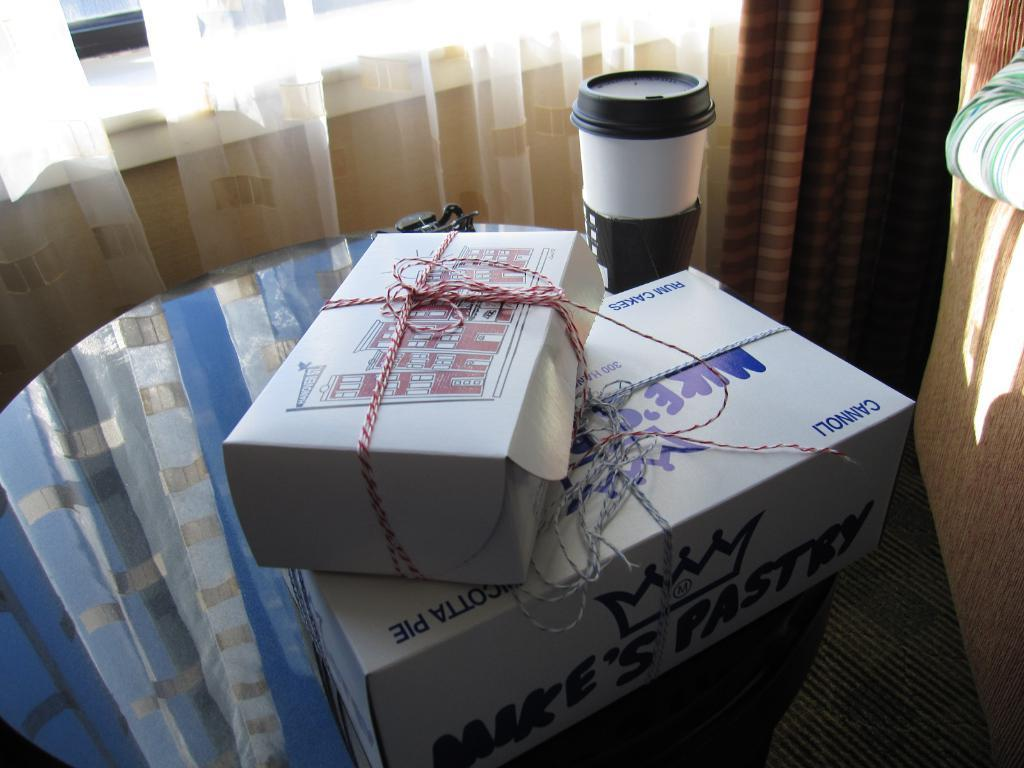Provide a one-sentence caption for the provided image. Two boxes are stacked, one of which contains cannoli. 